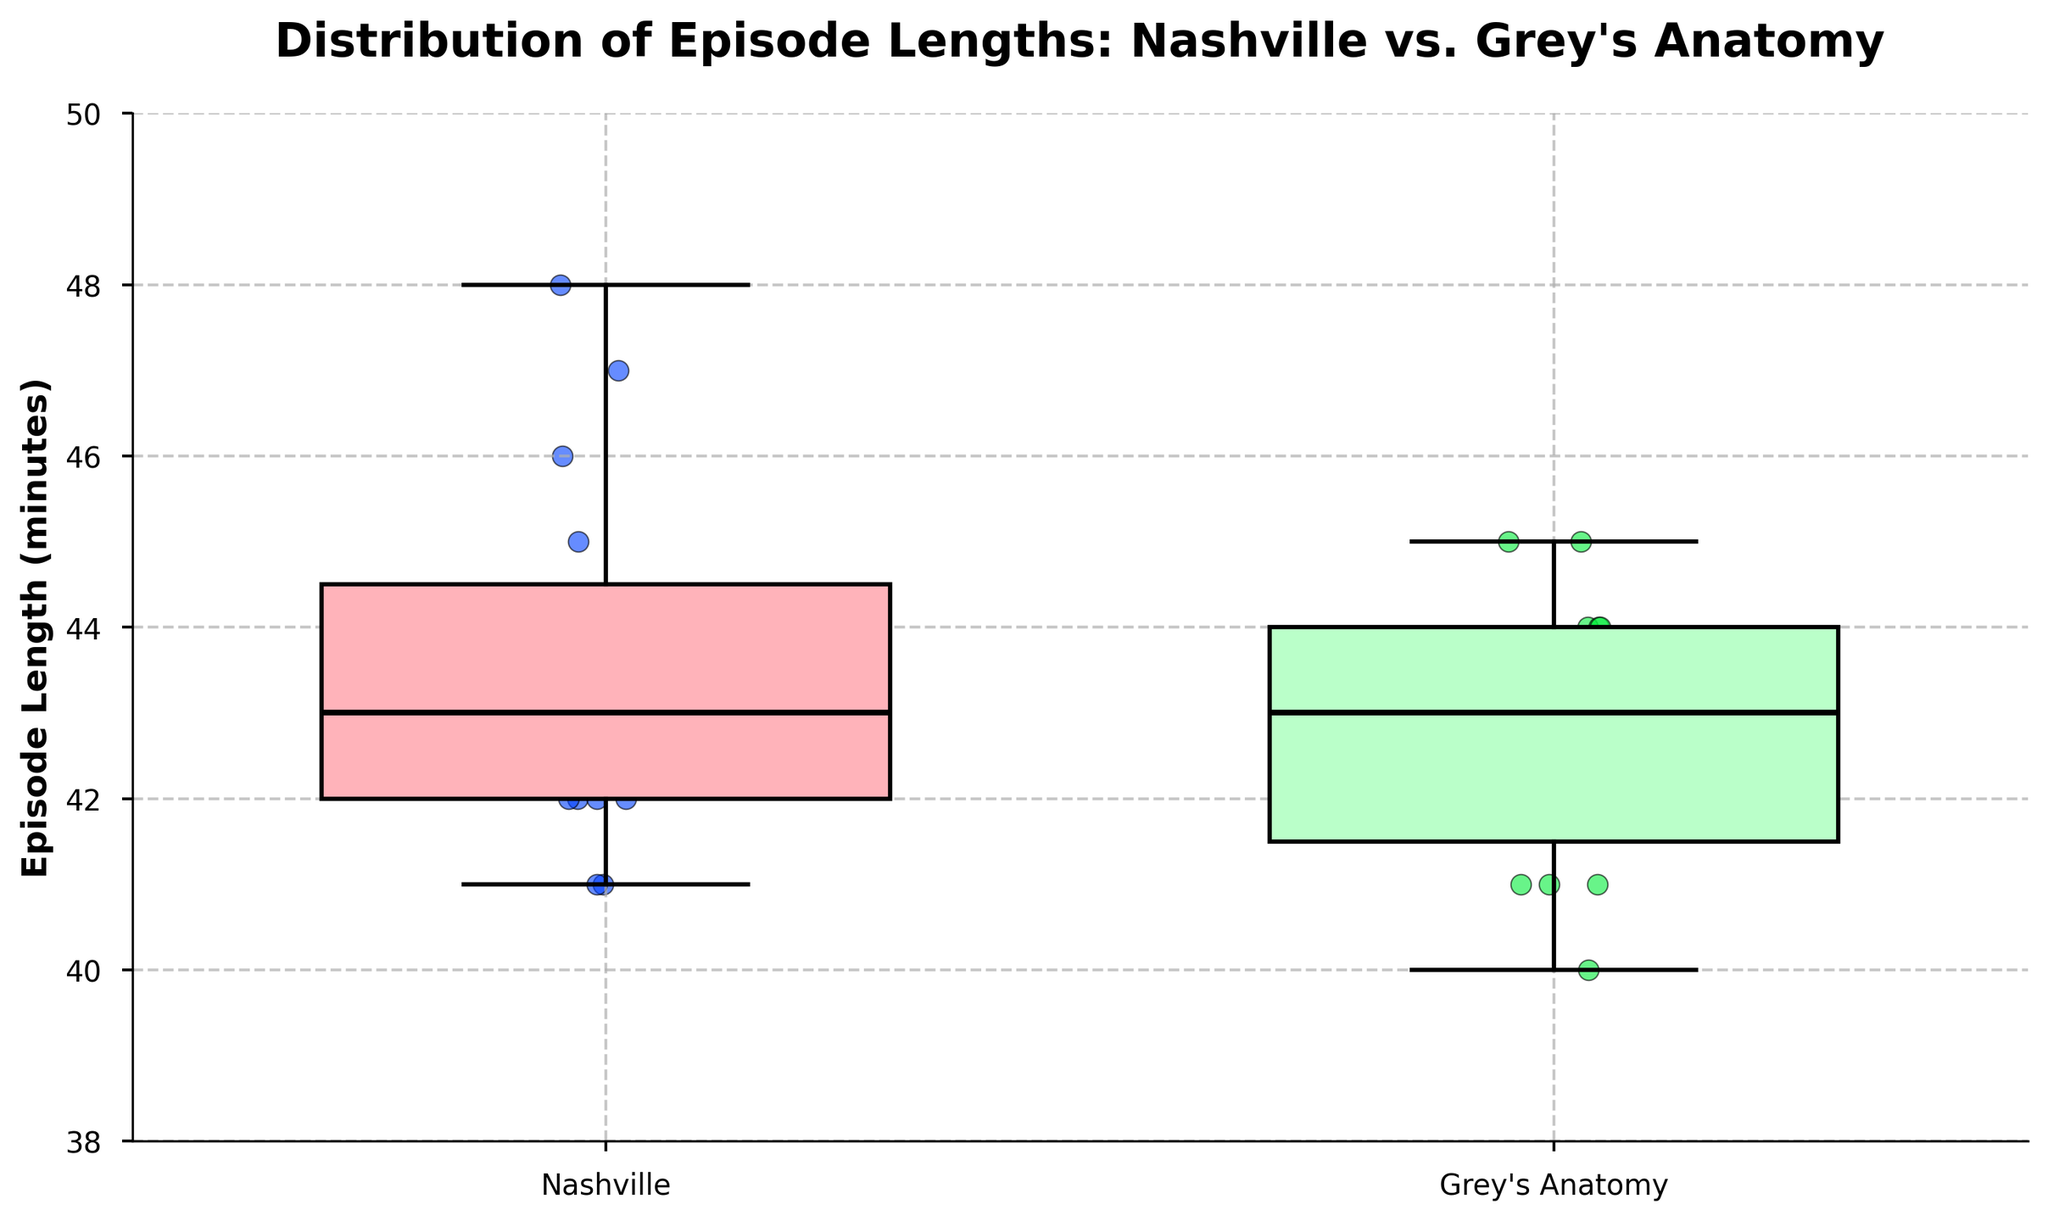What's the title of the plot? The title is usually located at the top of the plot and provides a brief description of what the plot represents. In this case, the title is "Distribution of Episode Lengths: Nashville vs. Grey's Anatomy".
Answer: Distribution of Episode Lengths: Nashville vs. Grey's Anatomy What's the median episode length for Nashville? The median is represented by the line inside the box of the box plot. For Nashville, this line is around 43 minutes.
Answer: 43 minutes Which show has a higher maximum episode length? The maximum value is indicated by the top whisker of the box plot. Nashville has a higher whisker reaching up to 48 minutes, whereas Grey's Anatomy reaches up to 45 minutes.
Answer: Nashville What is the interquartile range (IQR) for Grey's Anatomy? The IQR is the range between the first quartile (bottom edge of the box) and the third quartile (top edge of the box). For Grey's Anatomy, these values are approximately 41 and 44 minutes respectively. So, IQR = 44 - 41 = 3.
Answer: 3 minutes Between the two shows, which one has more variability in episode lengths? Variability can be observed through the length of the boxes and whiskers in the box plot. Nashville has a longer whisker, indicating greater variability.
Answer: Nashville What is the minimum episode length for Grey's Anatomy? The minimum value is represented by the bottom whisker of the box plot. For Grey's Anatomy, this point is at 40 minutes.
Answer: 40 minutes Which show has more episodes with lengths below 42 minutes? By looking at the scatter points below the 42-minute mark within each group, Grey's Anatomy appears to have slightly more episodes below this mark compared to Nashville.
Answer: Grey's Anatomy What episode length ranges fall between the first and third quartile for Nashville? For Nashville, the box represents the range between the first quartile (bottom of the box) and the third quartile (top of the box). These appear to be around 42 to 45 minutes.
Answer: 42 to 45 minutes How does the median episode length compare between the two shows? Comparing the lines inside the boxes, the medians for Nashville and Grey's Anatomy appear to be very close, around 43 minutes.
Answer: Almost equal 